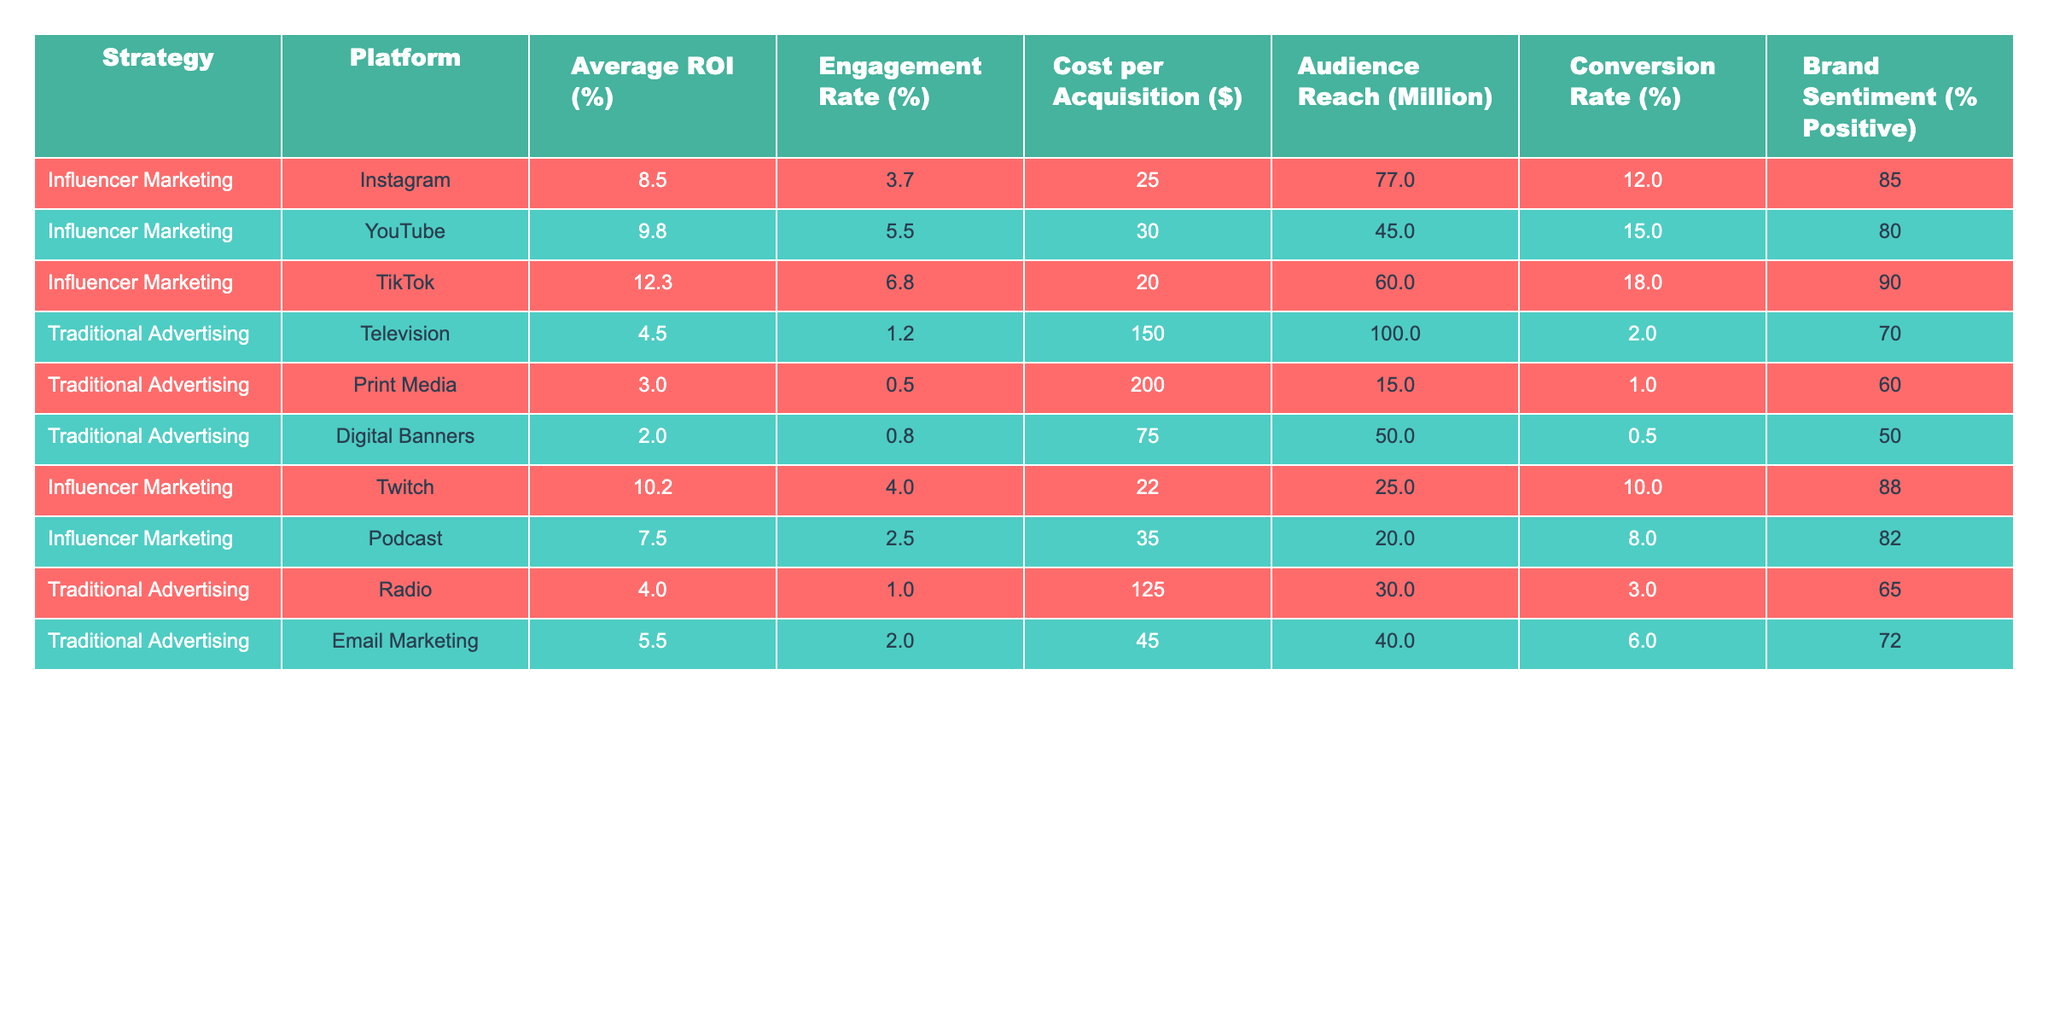What is the average ROI for Influencer Marketing on TikTok? The table shows that the average ROI for Influencer Marketing on TikTok is 12.3%.
Answer: 12.3% Which platform has the highest engagement rate in Influencer Marketing? From the table, TikTok shows the highest engagement rate at 6.8%.
Answer: TikTok What is the cost per acquisition for Traditional Advertising in Print Media? According to the table, the cost per acquisition for Traditional Advertising in Print Media is $200.
Answer: $200 What is the average conversion rate for Traditional Advertising? To find the average, we add the conversion rates of all Traditional Advertising types (2 + 1 + 0.5 + 3 + 6) = 12.5 and divide by the 5 entries, resulting in an average conversion rate of 2.5%.
Answer: 2.5% Does Influencer Marketing on YouTube have a higher ROI than Traditional Advertising on Television? Yes, the ROI for Influencer Marketing on YouTube is 9.8%, which is higher than the 4.5% ROI for Traditional Advertising on Television.
Answer: Yes Which strategy generally has a higher audience reach, Influencer Marketing or Traditional Advertising? By comparing the audience reach values, the maximum for Influencer Marketing is 77 million (Instagram), while Traditional Advertising has a maximum of 100 million (Television). Since Traditional Advertising has a higher reach, the answer is Traditional Advertising.
Answer: Traditional Advertising What is the brand sentiment for Influencer Marketing on Twitch? The table indicates that the brand sentiment for Influencer Marketing on Twitch is 88% positive.
Answer: 88% Calculate the difference in average ROI between Influencer Marketing on TikTok and Digital Banners in Traditional Advertising. The average ROI for Influencer Marketing on TikTok is 12.3%, and for Digital Banners, it is 2.0%. The difference is 12.3% - 2.0% = 10.3%.
Answer: 10.3% If you were to sum up the audience reach for all Traditional Advertising strategies, what would it be? Adding the audience reach values: 100 + 15 + 50 + 30 + 40 = 235 million.
Answer: 235 million Is the average cost per acquisition for Influencer Marketing lower than that for Traditional Advertising? For Influencer Marketing, the average cost per acquisition is (25 + 30 + 20 + 22 + 35)/5 = 32.4, and for Traditional Advertising, it is (150 + 200 + 75 + 125 + 45)/5 = 119. The average for Influencer Marketing is lower than Traditional Advertising.
Answer: Yes 